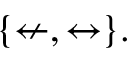Convert formula to latex. <formula><loc_0><loc_0><loc_500><loc_500>\{ \ n l e f t a r r o w , \leftrightarrow \} .</formula> 